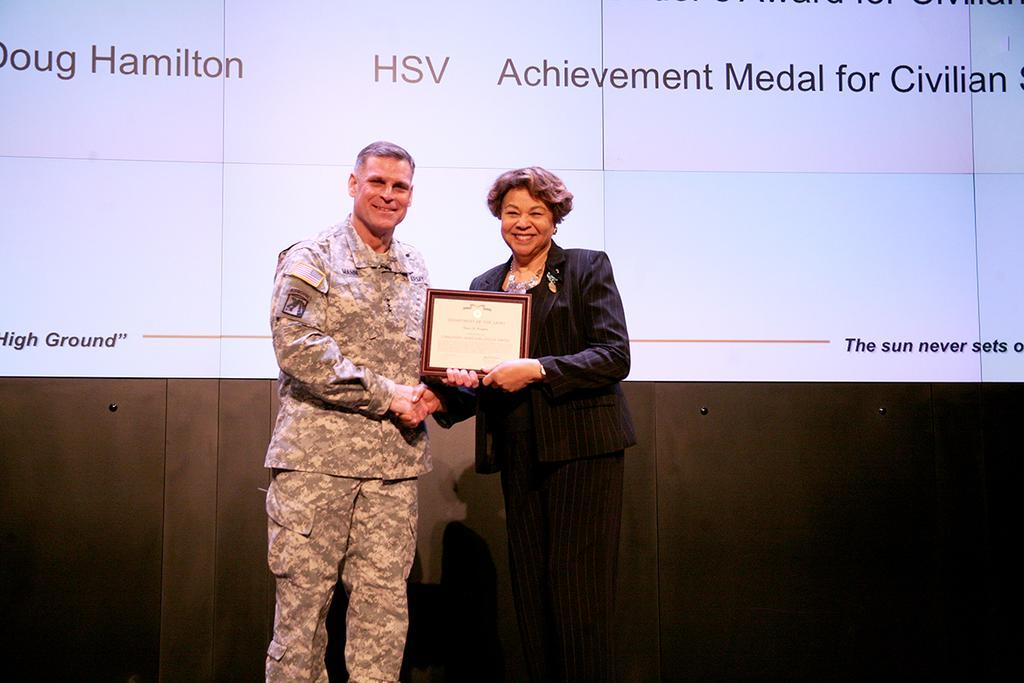Describe this image in one or two sentences. As we can see in the image there is a screen, photo frame and two people standing. The woman is wearing black color jacket and the man is wearing military dress. 